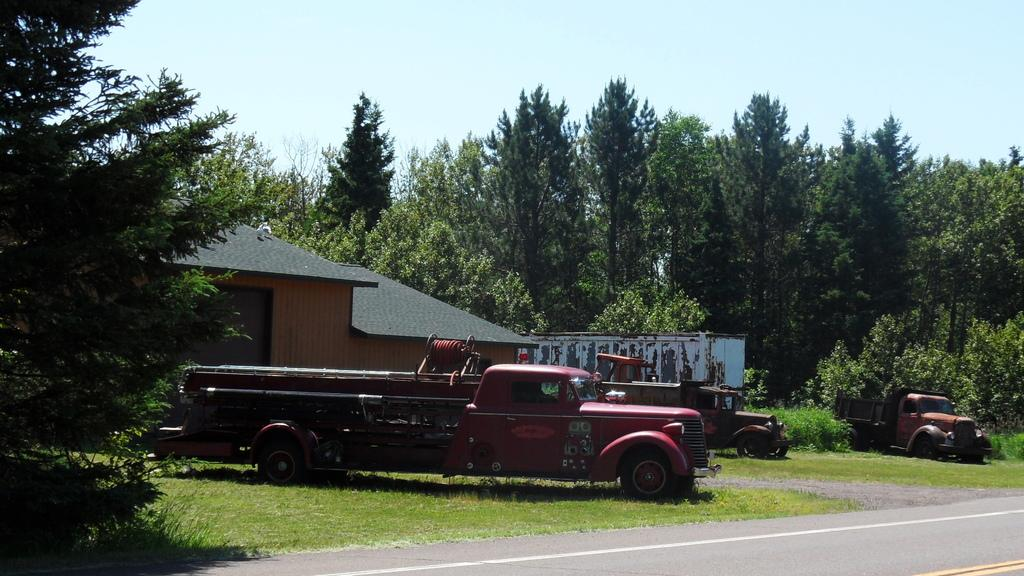What type of vehicles can be seen in the image? There are vehicles on the grass in the image. What can be seen in the background of the image? There is a house and trees in the background of the background. What is the color of the sky in the image? The sky is blue in color. Who is the owner of the observation tower in the image? There is no observation tower present in the image. 